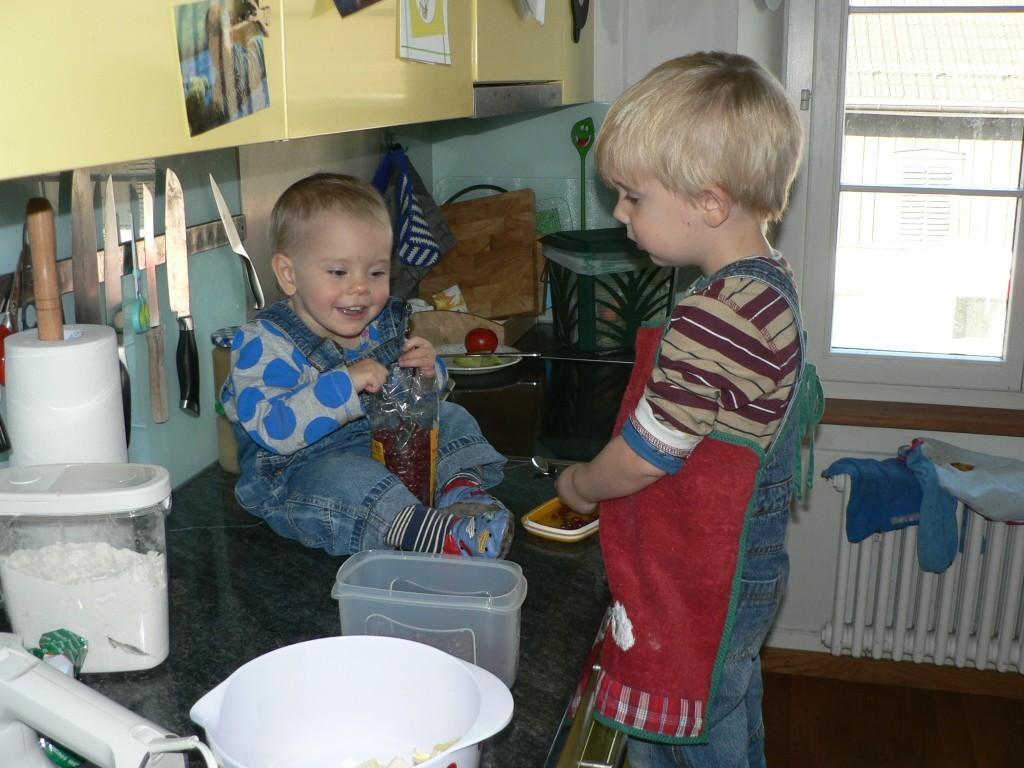How would you summarize this image in a sentence or two? The picture is clicked in a kitchen. At the center of the picture there are two kids, spoon, bottle, an object. On the left there are knives, tissue, foxes, flour and other objects. At the top there are posters attached to an object. In the center of the background there are cable, box and other objects. On the right, there are clothes and window, outside the window there is a building. 